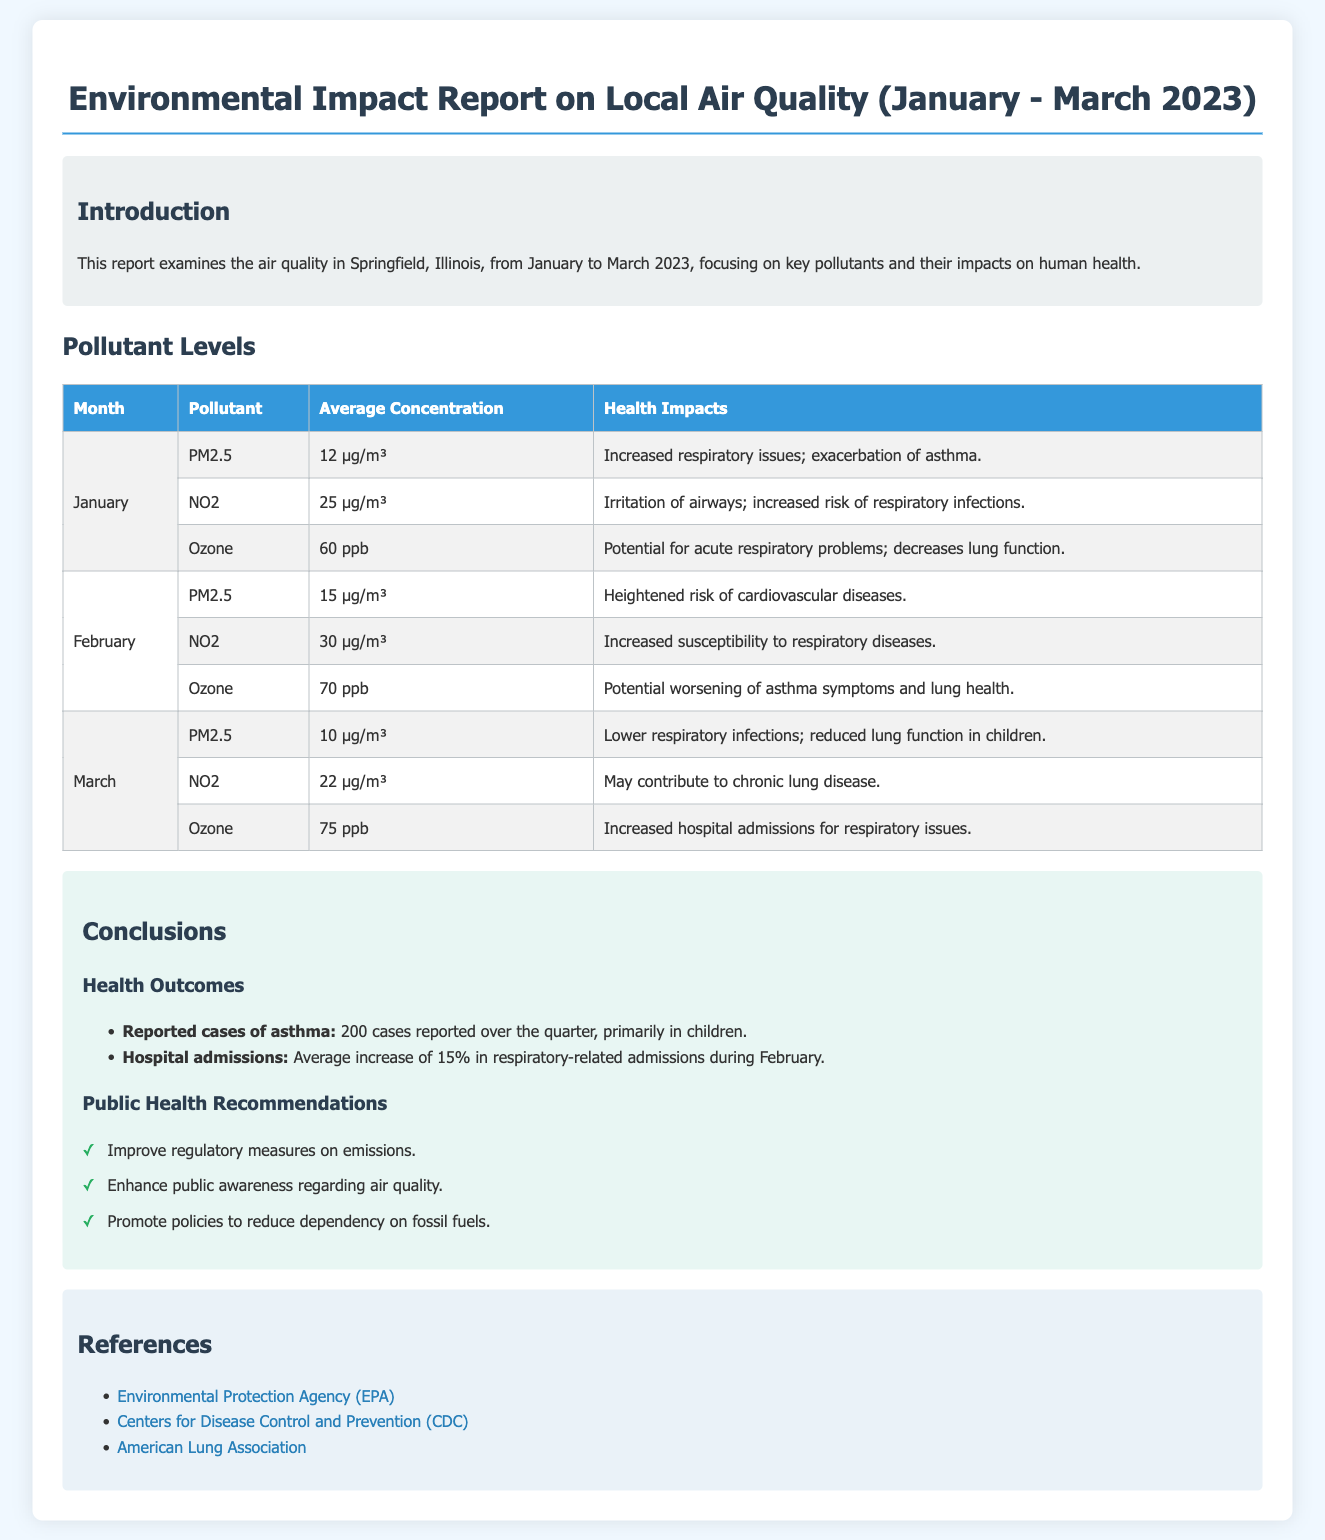What pollutants were measured in January? The document lists the pollutants measured in January as PM2.5, NO2, and Ozone.
Answer: PM2.5, NO2, Ozone What was the average concentration of NO2 in February? The average concentration of NO2 for February is specified in the table as 30 µg/m³.
Answer: 30 µg/m³ What was the average increase in respiratory-related hospital admissions during February? The report states that there was a 15% average increase in respiratory-related admissions during February.
Answer: 15% What health impact is associated with an average PM2.5 concentration of 15 µg/m³? The document mentions that this level of PM2.5 heightens the risk of cardiovascular diseases.
Answer: Heightened risk of cardiovascular diseases How many cases of asthma were reported over the quarter? The report indicates a total of 200 reported cases of asthma over the quarter.
Answer: 200 cases What was the average concentration of Ozone in March? According to the document, the average concentration of Ozone in March is 75 ppb.
Answer: 75 ppb What public health recommendation involves fossil fuels? One of the public health recommendations specifically promotes reducing dependency on fossil fuels.
Answer: Reduce dependency on fossil fuels What organization is listed as a reference in the document? The Environmental Protection Agency (EPA) is mentioned as one of the references in the document.
Answer: Environmental Protection Agency (EPA) 